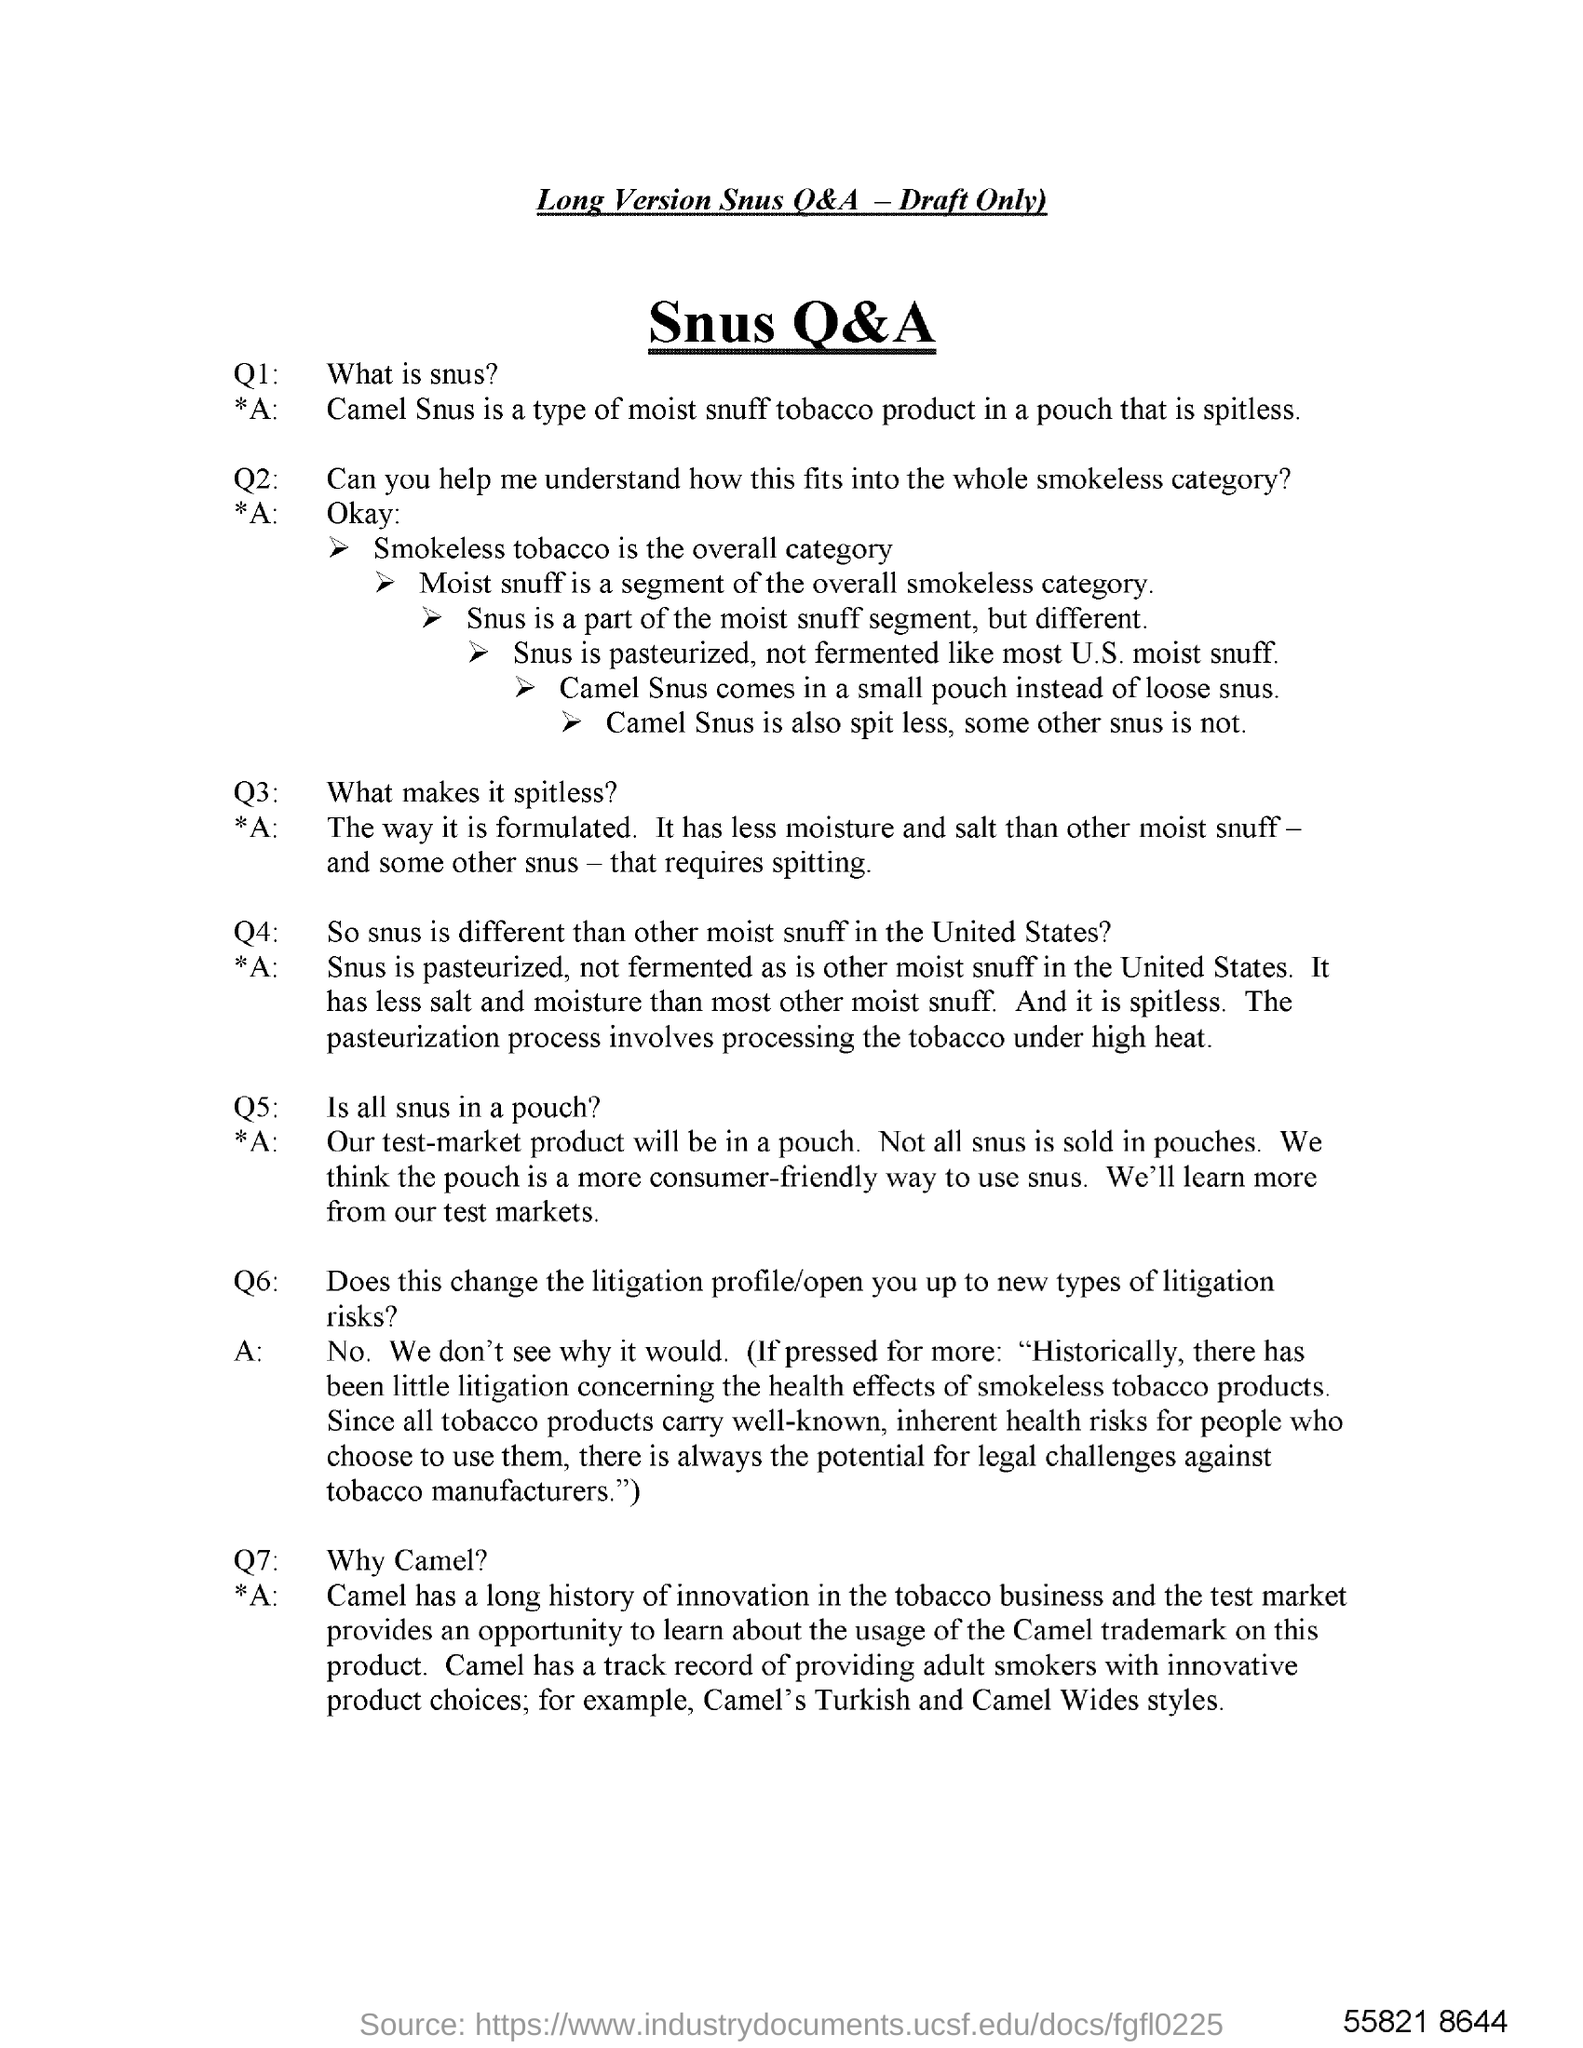Outline some significant characteristics in this image. Camel Snus is a type of moist snuff tobacco product that is packaged in a pouch and is designed to be spitless. 